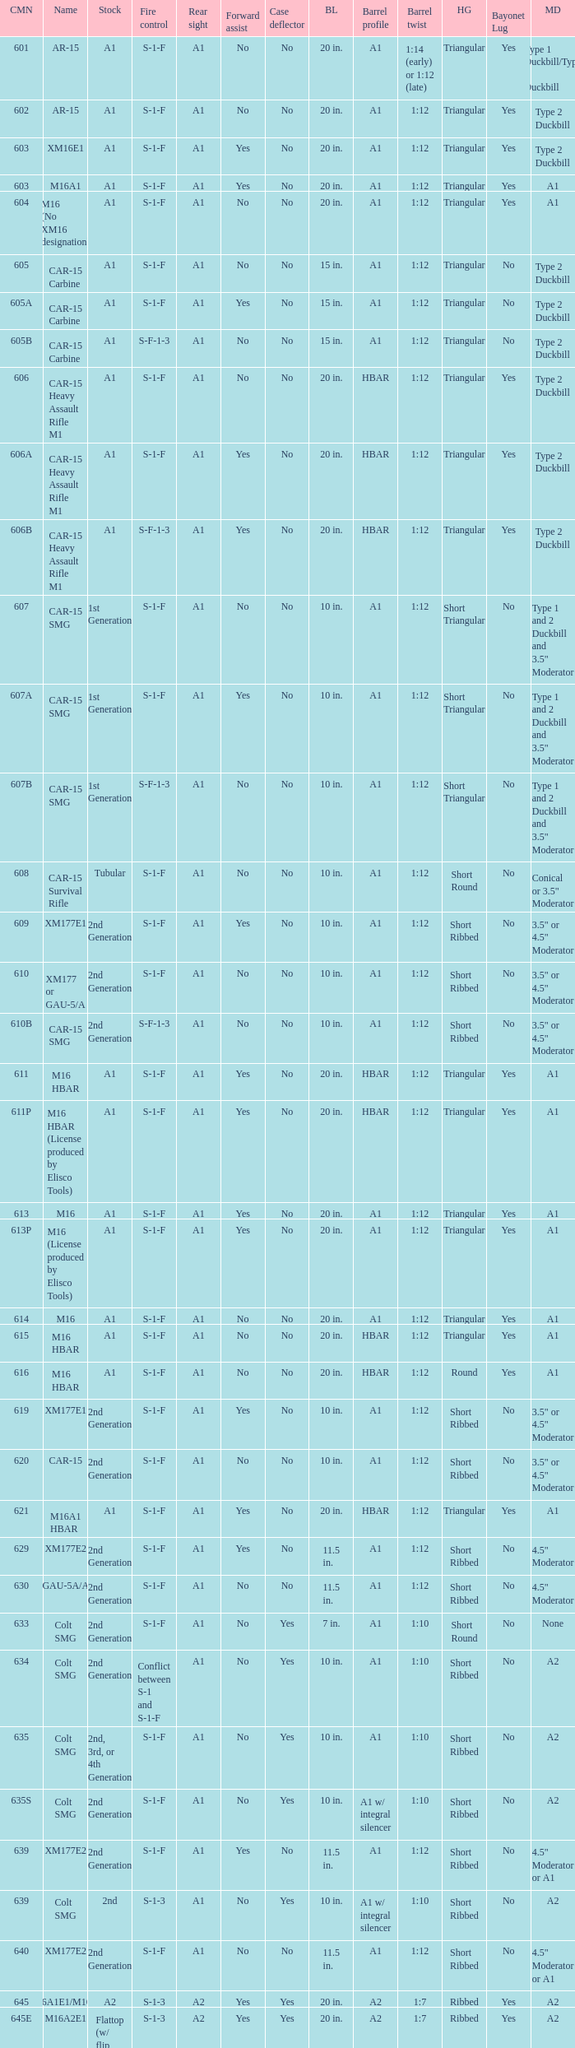What are the Colt model numbers of the models named GAU-5A/A, with no bayonet lug, no case deflector and stock of 2nd generation?  630, 649. 